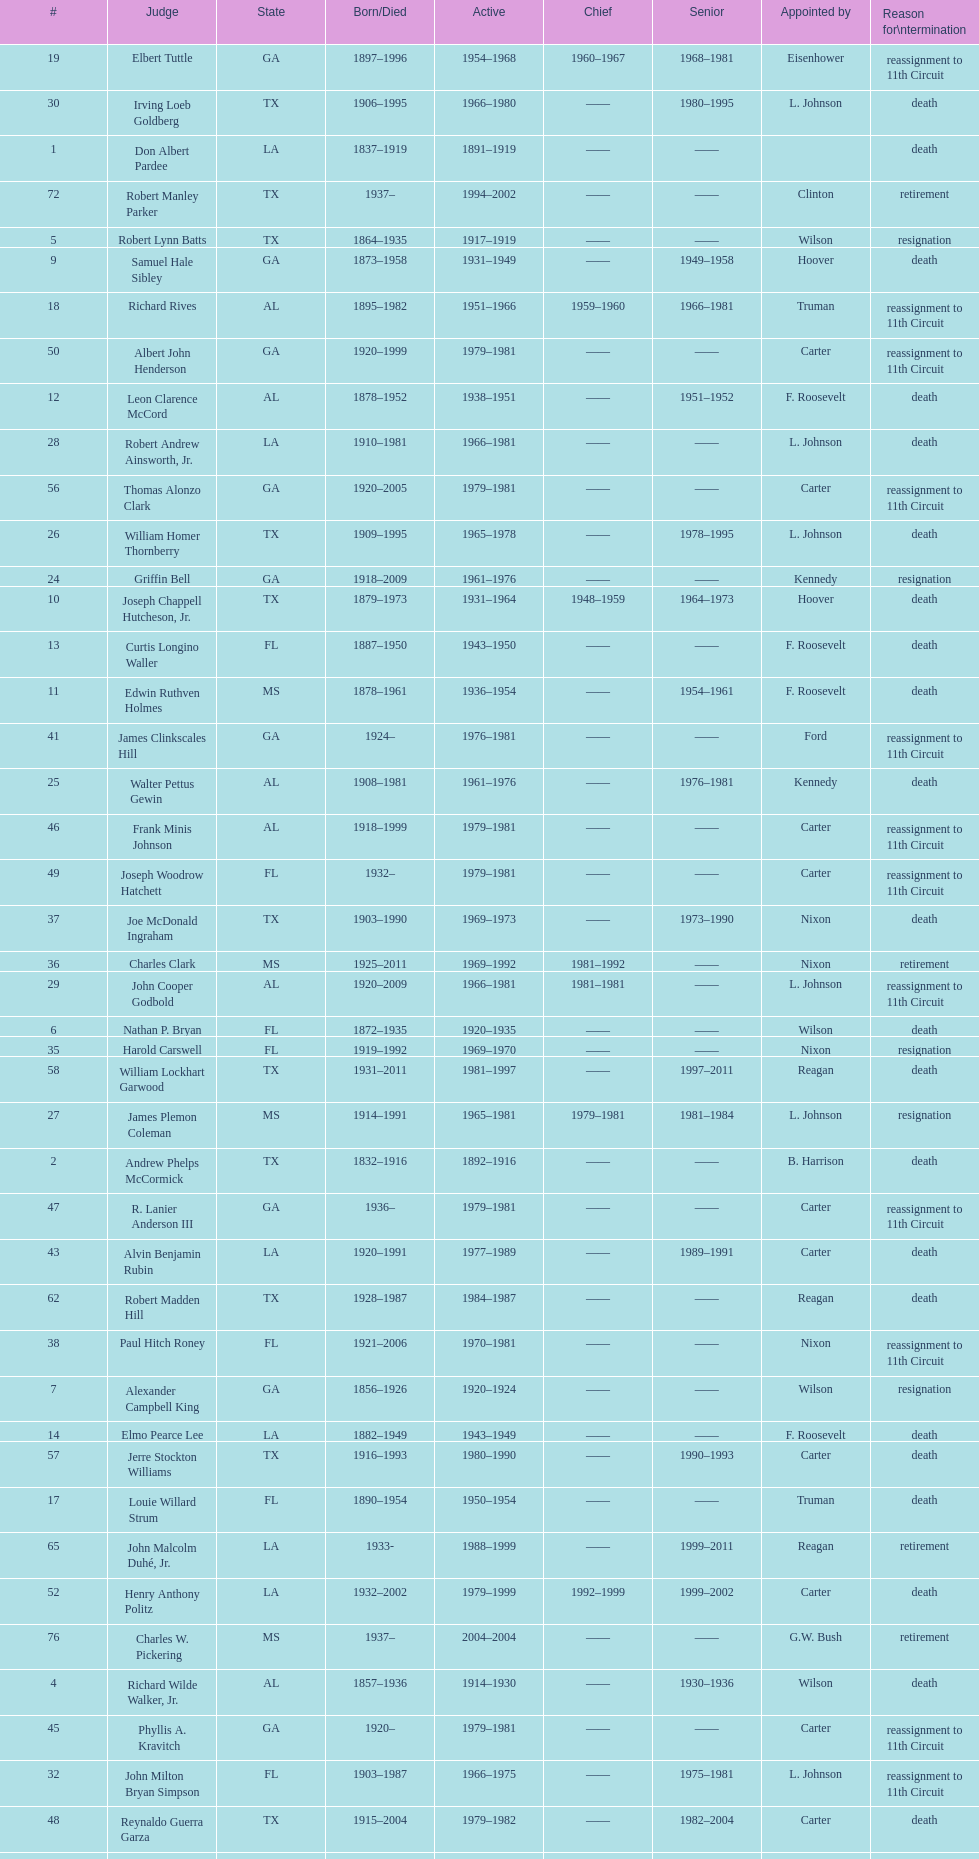How many judges served as chief total? 8. 